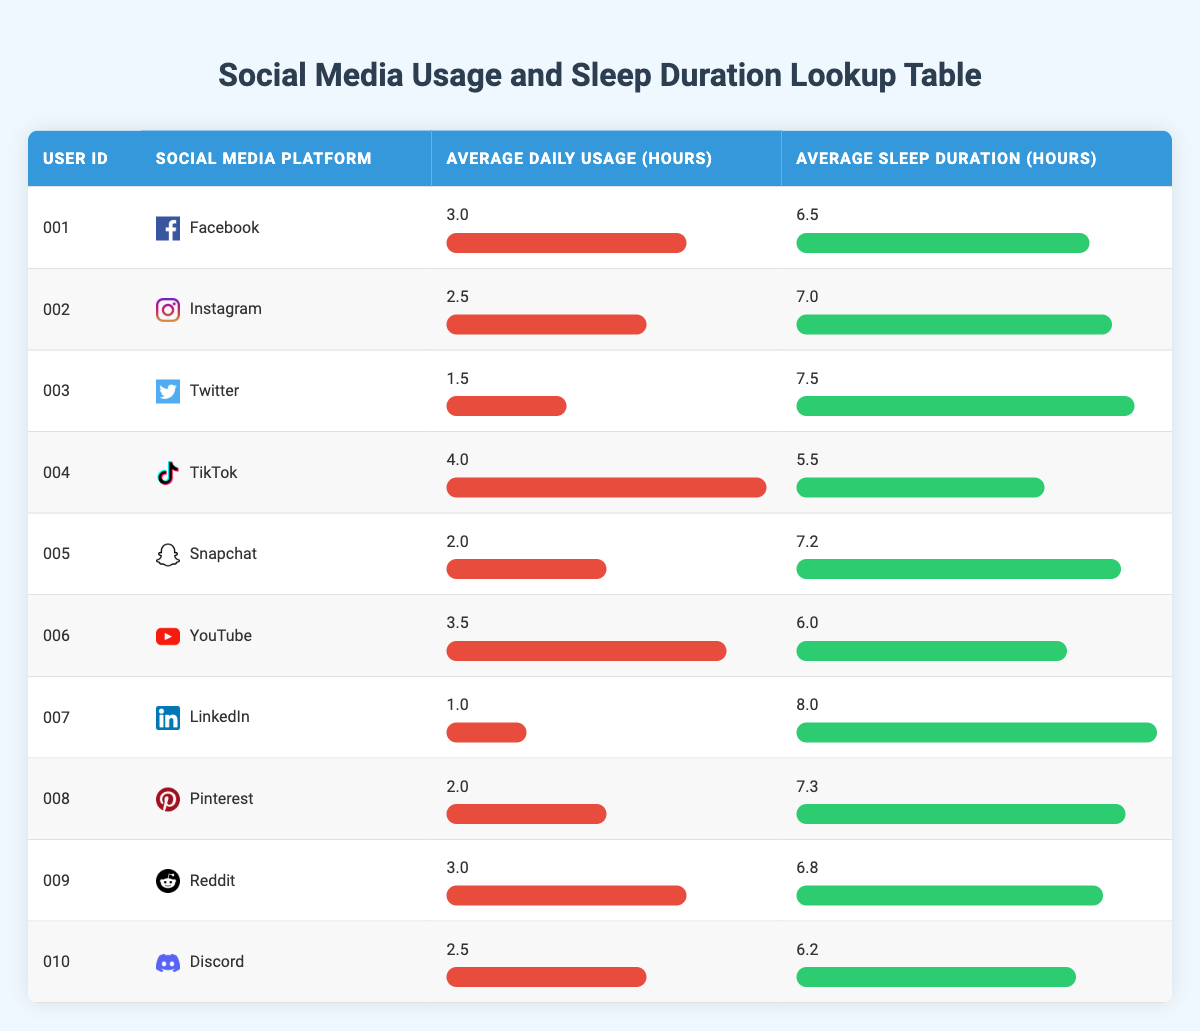What is the average sleep duration for users of Facebook? The table shows that the average sleep duration for the user with ID 001, who uses Facebook, is 6.5 hours. Therefore, since there's only one user in this case, the average sleep duration for Facebook users is simply 6.5 hours.
Answer: 6.5 Which social media platform is associated with the longest average sleep duration? By checking the sleep durations for each platform listed in the table, the longest average sleep duration is 8.0 hours for LinkedIn, associated with user ID 007.
Answer: LinkedIn What is the average daily usage for users who reported sleeping less than 7 hours? The table shows two users sleeping less than 7 hours: user ID 004 (TikTok, 4.0 hours usage) and user ID 006 (YouTube, 3.5 hours usage). Summing these gives 4.0 + 3.5 = 7.5 hours. Dividing by the two users gives an average usage of 7.5 / 2 = 3.75 hours.
Answer: 3.75 Is it true that users who spend more than 3 hours on social media sleep less than 7 hours on average? The users who spend more than 3 hours are user ID 001 (6.5 hours), 004 (5.5 hours), 006 (6.0 hours), and 009 (6.8 hours). Their average sleep duration is calculated as (6.5 + 5.5 + 6.0 + 6.8) / 4 = 6.45 hours. This is less than 7 hours, making the statement true.
Answer: Yes How much more sleep do users of Twitter get compared to users of TikTok? The average sleep duration for user ID 003 (Twitter) is 7.5 hours, while for user ID 004 (TikTok) it is 5.5 hours. The difference is 7.5 - 5.5 = 2.0 hours.
Answer: 2.0 What is the total average sleep duration for users from platforms that have an average daily usage of 2 hours or less? Only user ID 007 (LinkedIn) fits this criteria, with an average sleep duration of 8.0 hours. Since this is the only relevant data point, the total average is simply 8.0 hours.
Answer: 8.0 Which social media platform has the highest average daily usage, and what is that usage? The platform with the highest average daily usage is TikTok (user ID 004) at 4.0 hours. No other platforms exceed this daily usage as per the data.
Answer: TikTok, 4.0 Do users of Discord get more sleep than users of Snapchat? User ID 010 (Discord) has an average sleep duration of 6.2 hours, while user ID 005 (Snapchat) has 7.2 hours. Comparing these values, 6.2 is less than 7.2, so users of Discord sleep less.
Answer: No 